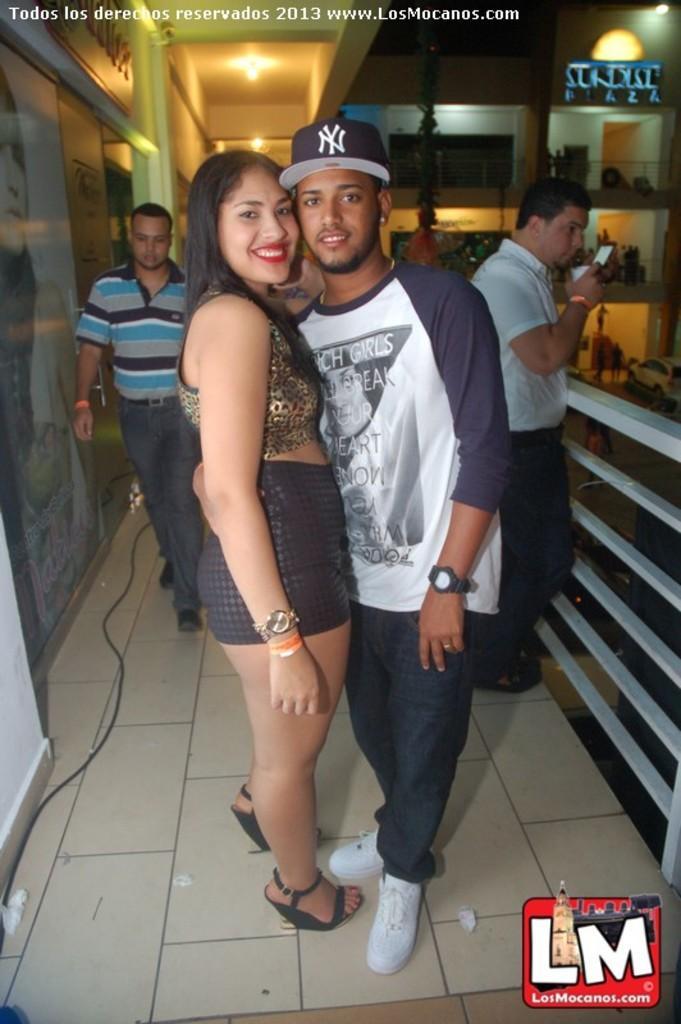How would you summarize this image in a sentence or two? In the picture there are two people standing in the front and posing for the photo and behind them there are another two people, on the left side there is a banner and beside the people there is a railing and in the background there are few balconies. 